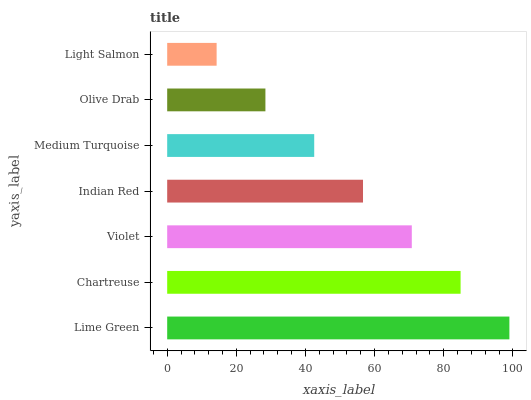Is Light Salmon the minimum?
Answer yes or no. Yes. Is Lime Green the maximum?
Answer yes or no. Yes. Is Chartreuse the minimum?
Answer yes or no. No. Is Chartreuse the maximum?
Answer yes or no. No. Is Lime Green greater than Chartreuse?
Answer yes or no. Yes. Is Chartreuse less than Lime Green?
Answer yes or no. Yes. Is Chartreuse greater than Lime Green?
Answer yes or no. No. Is Lime Green less than Chartreuse?
Answer yes or no. No. Is Indian Red the high median?
Answer yes or no. Yes. Is Indian Red the low median?
Answer yes or no. Yes. Is Violet the high median?
Answer yes or no. No. Is Medium Turquoise the low median?
Answer yes or no. No. 